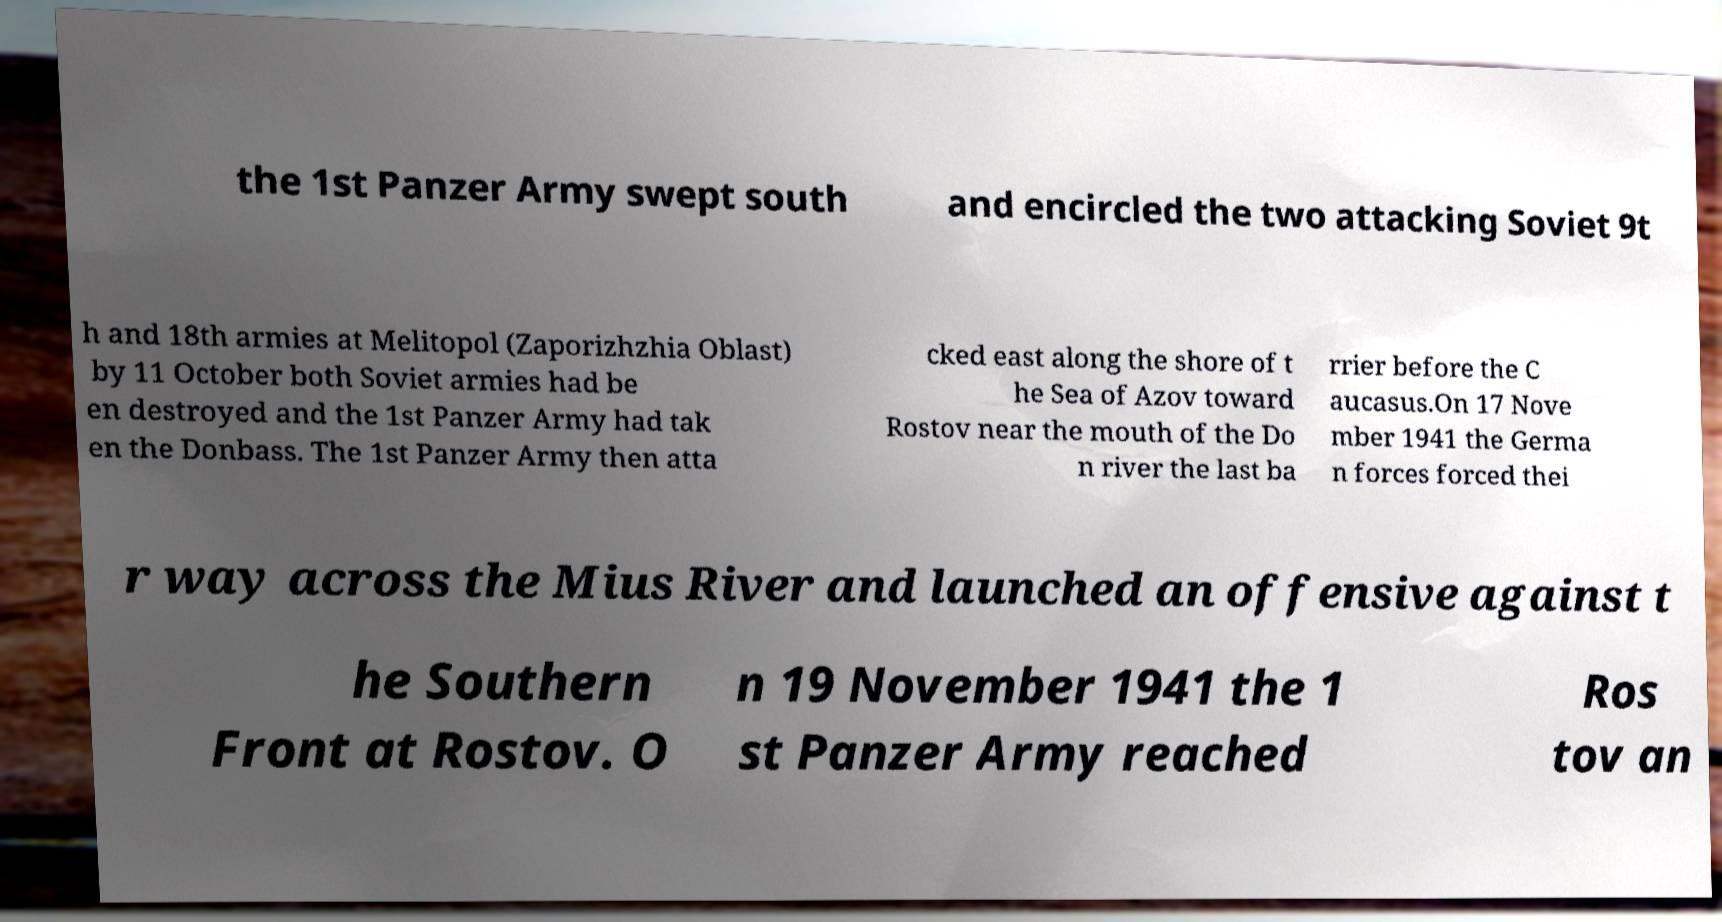Please identify and transcribe the text found in this image. the 1st Panzer Army swept south and encircled the two attacking Soviet 9t h and 18th armies at Melitopol (Zaporizhzhia Oblast) by 11 October both Soviet armies had be en destroyed and the 1st Panzer Army had tak en the Donbass. The 1st Panzer Army then atta cked east along the shore of t he Sea of Azov toward Rostov near the mouth of the Do n river the last ba rrier before the C aucasus.On 17 Nove mber 1941 the Germa n forces forced thei r way across the Mius River and launched an offensive against t he Southern Front at Rostov. O n 19 November 1941 the 1 st Panzer Army reached Ros tov an 